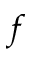<formula> <loc_0><loc_0><loc_500><loc_500>f</formula> 